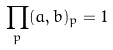Convert formula to latex. <formula><loc_0><loc_0><loc_500><loc_500>\prod _ { p } ( a , b ) _ { p } = 1</formula> 